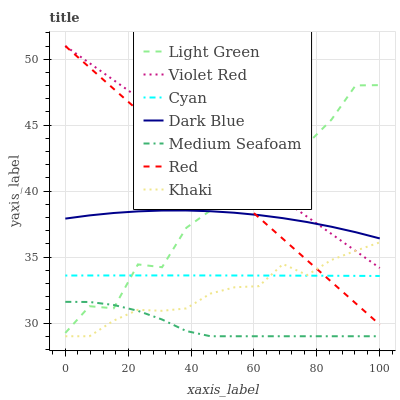Does Khaki have the minimum area under the curve?
Answer yes or no. No. Does Khaki have the maximum area under the curve?
Answer yes or no. No. Is Khaki the smoothest?
Answer yes or no. No. Is Khaki the roughest?
Answer yes or no. No. Does Dark Blue have the lowest value?
Answer yes or no. No. Does Khaki have the highest value?
Answer yes or no. No. Is Medium Seafoam less than Red?
Answer yes or no. Yes. Is Dark Blue greater than Cyan?
Answer yes or no. Yes. Does Medium Seafoam intersect Red?
Answer yes or no. No. 